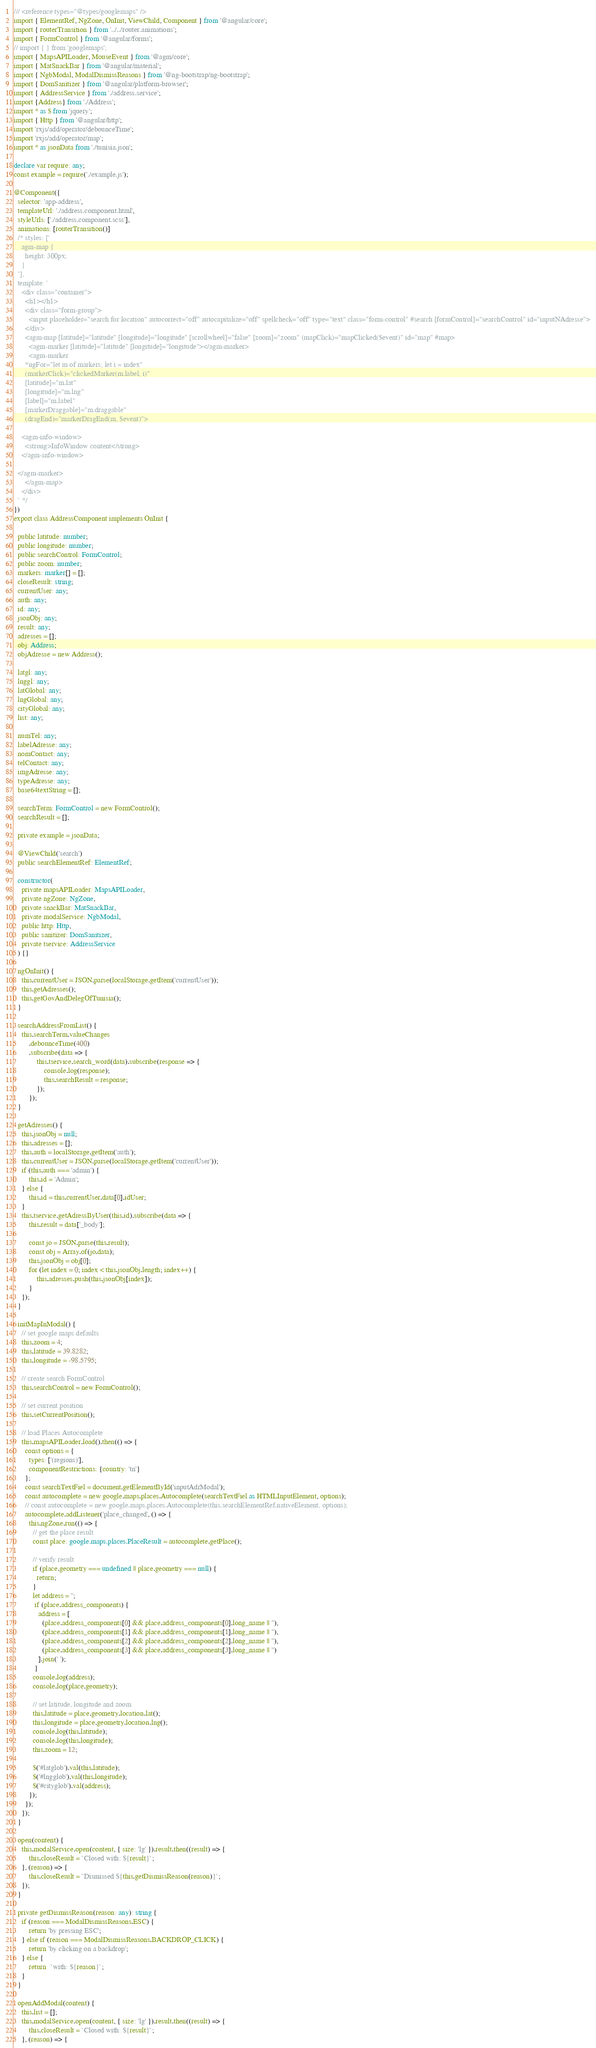<code> <loc_0><loc_0><loc_500><loc_500><_TypeScript_>/// <reference types="@types/googlemaps" />
import { ElementRef, NgZone, OnInit, ViewChild, Component } from '@angular/core';
import { routerTransition } from '../../router.animations';
import { FormControl } from '@angular/forms';
// import { } from 'googlemaps';
import { MapsAPILoader, MouseEvent } from '@agm/core';
import { MatSnackBar } from '@angular/material';
import { NgbModal, ModalDismissReasons } from '@ng-bootstrap/ng-bootstrap';
import { DomSanitizer } from '@angular/platform-browser';
import { AddressService } from './address.service';
import {Address} from './Address';
import * as $ from 'jquery';
import { Http } from '@angular/http';
import 'rxjs/add/operator/debounceTime';
import 'rxjs/add/operator/map';
import * as jsonData from './tunisia.json';

declare var require: any;
const example = require('./example.js');

@Component({
  selector: 'app-address',
  templateUrl: './address.component.html',
  styleUrls: ['./address.component.scss'],
  animations: [routerTransition()]
  /* styles: [`
    agm-map {
      height: 300px;
    }
  `],
  template: `
    <div class="container">
      <h1></h1>
      <div class="form-group">
        <input placeholder="search for location" autocorrect="off" autocapitalize="off" spellcheck="off" type="text" class="form-control" #search [formControl]="searchControl" id="inputNAdresse">
      </div>
      <agm-map [latitude]="latitude" [longitude]="longitude" [scrollwheel]="false" [zoom]="zoom" (mapClick)="mapClicked($event)" id="map" #map>
        <agm-marker [latitude]="latitude" [longitude]="longitude"></agm-marker>
        <agm-marker
      *ngFor="let m of markers; let i = index"
      (markerClick)="clickedMarker(m.label, i)"
      [latitude]="m.lat"
      [longitude]="m.lng"
      [label]="m.label"
      [markerDraggable]="m.draggable"
      (dragEnd)="markerDragEnd(m, $event)">

    <agm-info-window>
      <strong>InfoWindow content</strong>
    </agm-info-window>

  </agm-marker>
      </agm-map>
    </div>
  ` */
})
export class AddressComponent implements OnInit {

  public latitude: number;
  public longitude: number;
  public searchControl: FormControl;
  public zoom: number;
  markers: marker[] = [];
  closeResult: string;
  currentUser: any;
  auth: any;
  id: any;
  jsonObj: any;
  result: any;
  adresses = [];
  obj: Address;
  objAdresse = new Address();

  latgl: any;
  lnggl: any;
  latGlobal: any;
  lngGlobal: any;
  cityGlobal: any;
  list: any;

  numTel: any;
  labelAdresse: any;
  nomContact: any;
  telContact: any;
  imgAdresse: any;
  typeAdresse: any;
  base64textString = [];

  searchTerm: FormControl = new FormControl();
  searchResult = [];

  private example = jsonData;

  @ViewChild('search')
  public searchElementRef: ElementRef;

  constructor(
    private mapsAPILoader: MapsAPILoader,
    private ngZone: NgZone,
    private snackBar: MatSnackBar,
    private modalService: NgbModal,
    public http: Http,
    public sanitizer: DomSanitizer,
    private tservice: AddressService
  ) {}

  ngOnInit() {
    this.currentUser = JSON.parse(localStorage.getItem('currentUser'));
    this.getAdresses();
    this.getGovAndDelegOfTunisia();
  }

  searchAddressFromList() {
    this.searchTerm.valueChanges
   		.debounceTime(400)
   		.subscribe(data => {
   			this.tservice.search_word(data).subscribe(response => {
   				console.log(response);
   				this.searchResult = response;
   			});
   		});
  }

  getAdresses() {
    this.jsonObj = null;
    this.adresses = [];
    this.auth = localStorage.getItem('auth');
    this.currentUser = JSON.parse(localStorage.getItem('currentUser'));
    if (this.auth === 'admin') {
        this.id = 'Admin';
    } else {
        this.id = this.currentUser.data[0].idUser;
    }
    this.tservice.getAdressByUser(this.id).subscribe(data => {
        this.result = data['_body'];

        const jo = JSON.parse(this.result);
        const obj = Array.of(jo.data);
        this.jsonObj = obj[0];
        for (let index = 0; index < this.jsonObj.length; index++) {
            this.adresses.push(this.jsonObj[index]);
        }
    });
  }

  initMapInModal() {
    // set google maps defaults
    this.zoom = 4;
    this.latitude = 39.8282;
    this.longitude = -98.5795;

    // create search FormControl
    this.searchControl = new FormControl();

    // set current position
    this.setCurrentPosition();

    // load Places Autocomplete
    this.mapsAPILoader.load().then(() => {
      const options = {
        types: ['(regions)'],
        componentRestrictions: {country: 'tn'}
      };
      const searchTextFiel = document.getElementById('inputAdrModal');
      const autocomplete = new google.maps.places.Autocomplete(searchTextFiel as HTMLInputElement, options);
      // const autocomplete = new google.maps.places.Autocomplete(this.searchElementRef.nativeElement, options);
      autocomplete.addListener('place_changed', () => {
        this.ngZone.run(() => {
          // get the place result
          const place: google.maps.places.PlaceResult = autocomplete.getPlace();

          // verify result
          if (place.geometry === undefined || place.geometry === null) {
            return;
          }
          let address = '';
           if (place.address_components) {
             address = [
               (place.address_components[0] && place.address_components[0].long_name || ''),
               (place.address_components[1] && place.address_components[1].long_name || ''),
               (place.address_components[2] && place.address_components[2].long_name || ''),
               (place.address_components[3] && place.address_components[3].long_name || '')
             ].join(' ');
           }
          console.log(address);
          console.log(place.geometry);

          // set latitude, longitude and zoom
          this.latitude = place.geometry.location.lat();
          this.longitude = place.geometry.location.lng();
          console.log(this.latitude);
          console.log(this.longitude);
          this.zoom = 12;

          $('#latglob').val(this.latitude);
          $('#lngglob').val(this.longitude);
          $('#cityglob').val(address);
        });
      });
    });
  }

  open(content) {
    this.modalService.open(content, { size: 'lg' }).result.then((result) => {
        this.closeResult = `Closed with: ${result}`;
    }, (reason) => {
        this.closeResult = `Dismissed ${this.getDismissReason(reason)}`;
    });
  }

  private getDismissReason(reason: any): string {
    if (reason === ModalDismissReasons.ESC) {
        return 'by pressing ESC';
    } else if (reason === ModalDismissReasons.BACKDROP_CLICK) {
        return 'by clicking on a backdrop';
    } else {
        return  `with: ${reason}`;
    }
  }

  openAddModal(content) {
    this.list = [];
    this.modalService.open(content, { size: 'lg' }).result.then((result) => {
        this.closeResult = `Closed with: ${result}`;
    }, (reason) => {</code> 